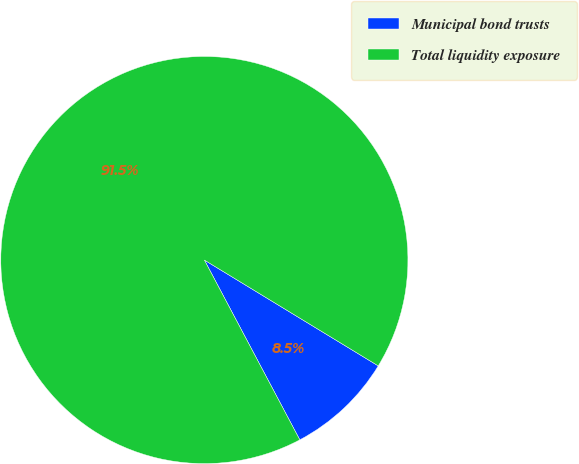Convert chart to OTSL. <chart><loc_0><loc_0><loc_500><loc_500><pie_chart><fcel>Municipal bond trusts<fcel>Total liquidity exposure<nl><fcel>8.53%<fcel>91.47%<nl></chart> 